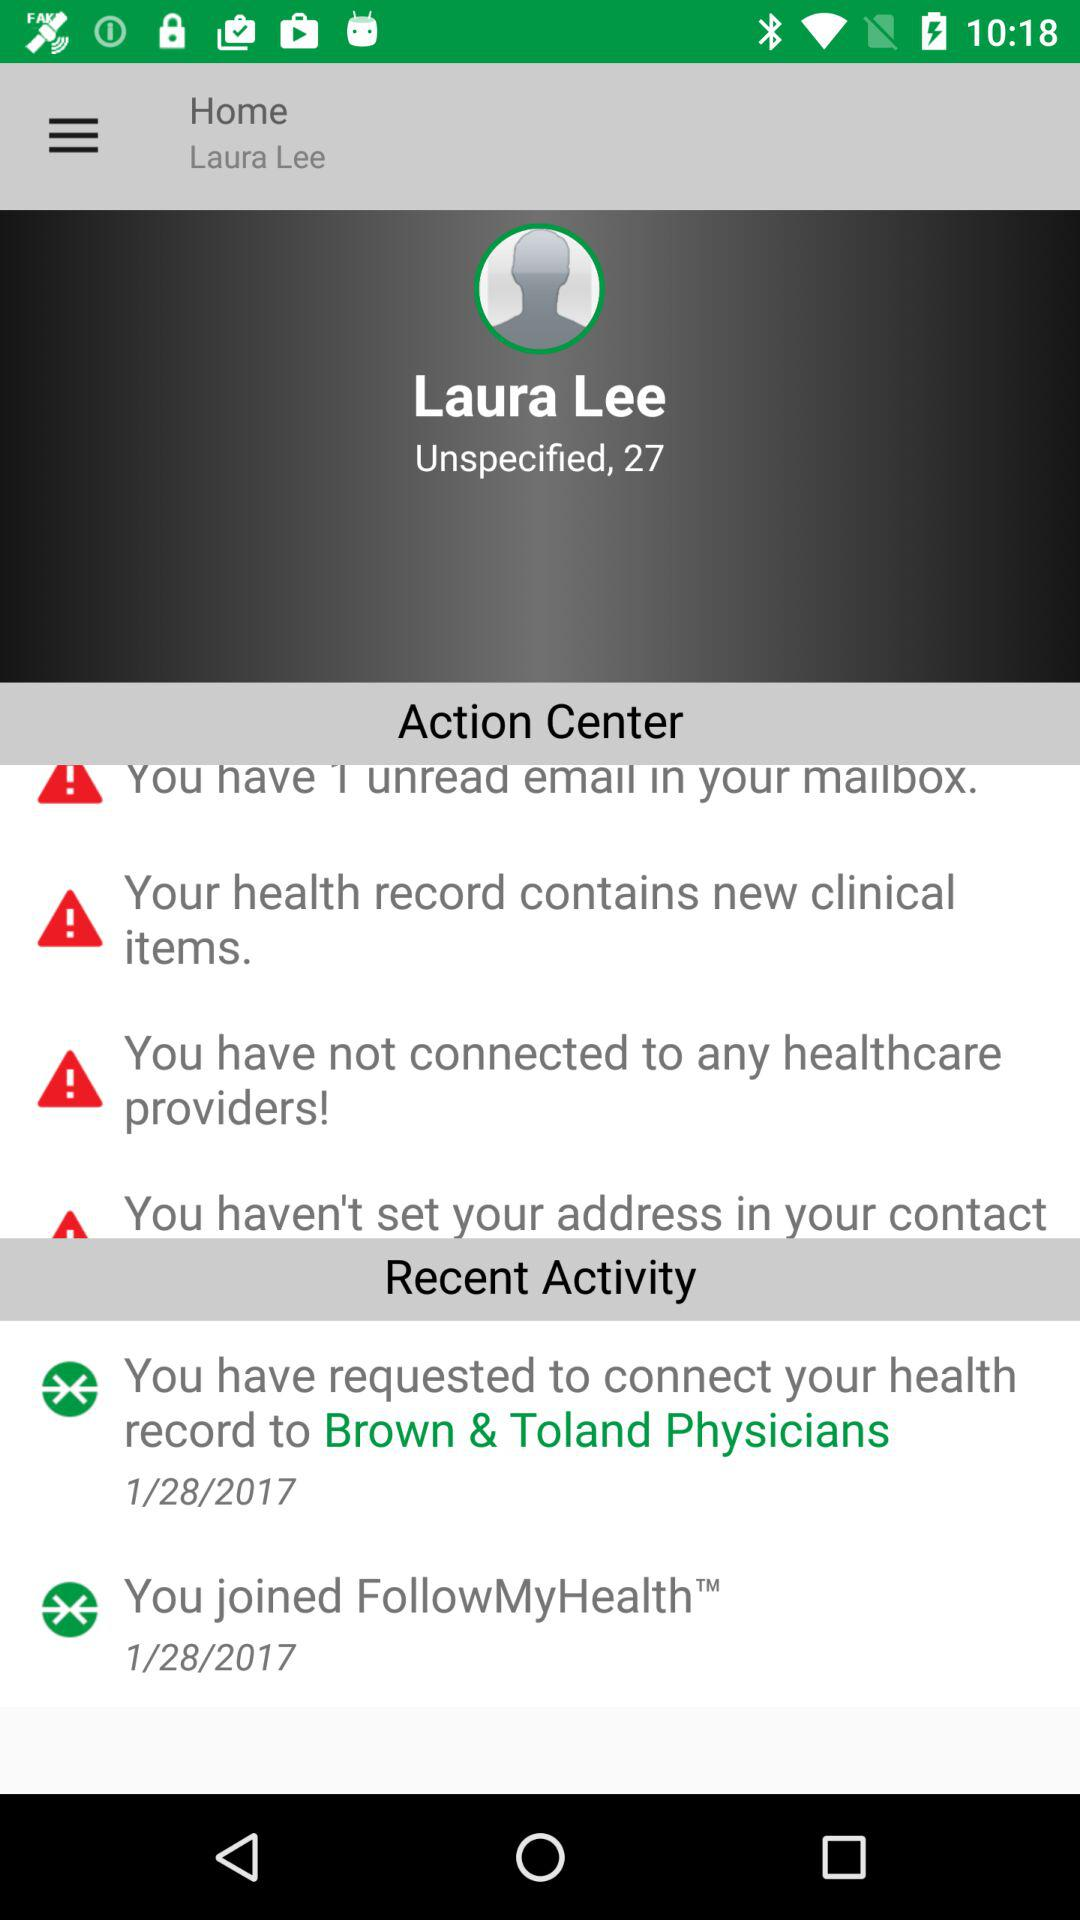How many unread emails are in Laura Lee's mailbox?
Answer the question using a single word or phrase. 1 